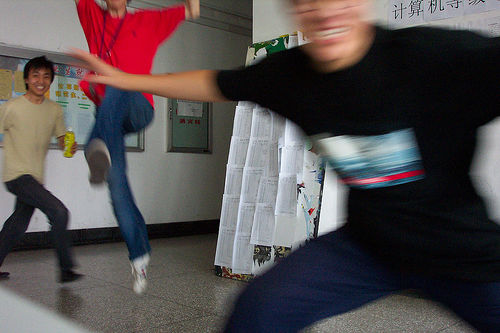What is the quality of the image? The quality of the image is low; it's blurry, with the motion of the subjects causing a lack of sharpness and fine detail. This suggests the photo was taken with a quick shutter speed in a casually captured moment, possibly with a low-resolution camera or in low light conditions. 